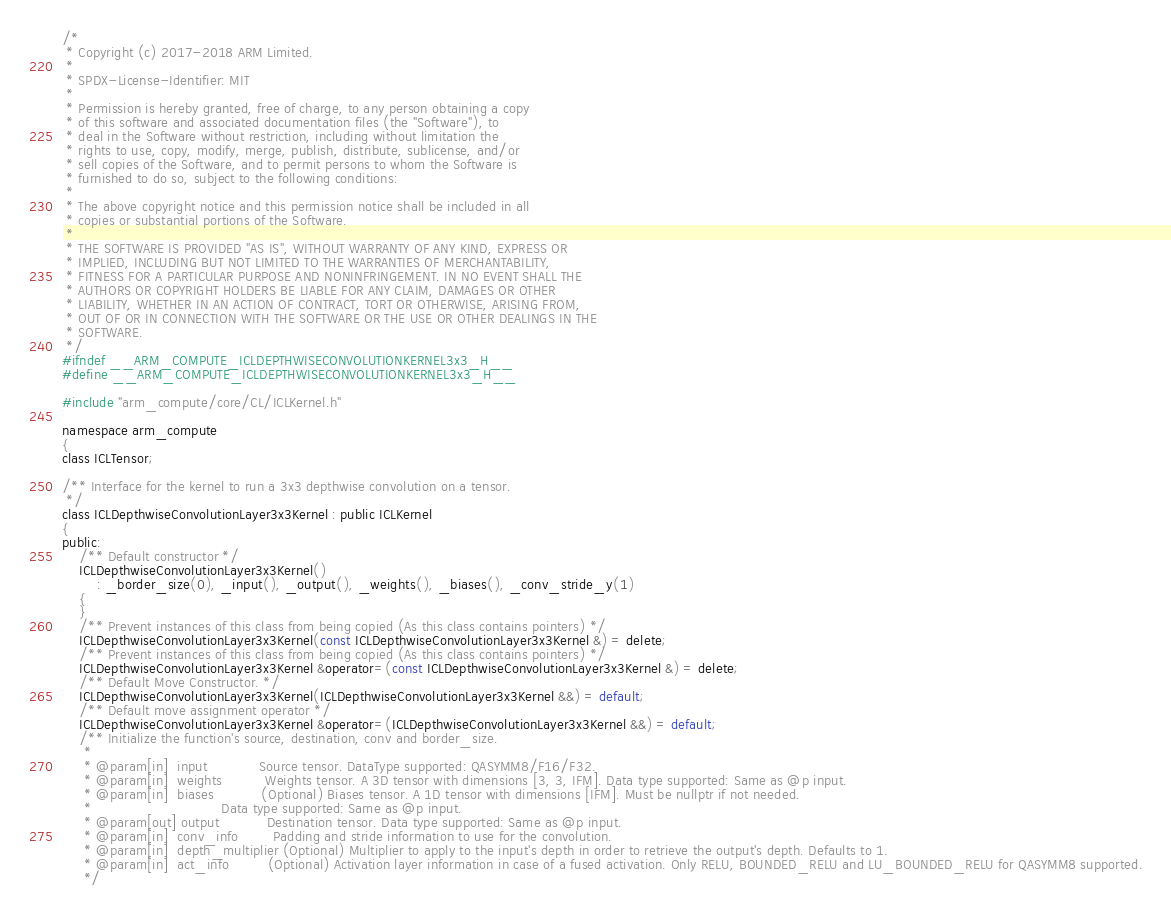Convert code to text. <code><loc_0><loc_0><loc_500><loc_500><_C_>/*
 * Copyright (c) 2017-2018 ARM Limited.
 *
 * SPDX-License-Identifier: MIT
 *
 * Permission is hereby granted, free of charge, to any person obtaining a copy
 * of this software and associated documentation files (the "Software"), to
 * deal in the Software without restriction, including without limitation the
 * rights to use, copy, modify, merge, publish, distribute, sublicense, and/or
 * sell copies of the Software, and to permit persons to whom the Software is
 * furnished to do so, subject to the following conditions:
 *
 * The above copyright notice and this permission notice shall be included in all
 * copies or substantial portions of the Software.
 *
 * THE SOFTWARE IS PROVIDED "AS IS", WITHOUT WARRANTY OF ANY KIND, EXPRESS OR
 * IMPLIED, INCLUDING BUT NOT LIMITED TO THE WARRANTIES OF MERCHANTABILITY,
 * FITNESS FOR A PARTICULAR PURPOSE AND NONINFRINGEMENT. IN NO EVENT SHALL THE
 * AUTHORS OR COPYRIGHT HOLDERS BE LIABLE FOR ANY CLAIM, DAMAGES OR OTHER
 * LIABILITY, WHETHER IN AN ACTION OF CONTRACT, TORT OR OTHERWISE, ARISING FROM,
 * OUT OF OR IN CONNECTION WITH THE SOFTWARE OR THE USE OR OTHER DEALINGS IN THE
 * SOFTWARE.
 */
#ifndef __ARM_COMPUTE_ICLDEPTHWISECONVOLUTIONKERNEL3x3_H__
#define __ARM_COMPUTE_ICLDEPTHWISECONVOLUTIONKERNEL3x3_H__

#include "arm_compute/core/CL/ICLKernel.h"

namespace arm_compute
{
class ICLTensor;

/** Interface for the kernel to run a 3x3 depthwise convolution on a tensor.
 */
class ICLDepthwiseConvolutionLayer3x3Kernel : public ICLKernel
{
public:
    /** Default constructor */
    ICLDepthwiseConvolutionLayer3x3Kernel()
        : _border_size(0), _input(), _output(), _weights(), _biases(), _conv_stride_y(1)
    {
    }
    /** Prevent instances of this class from being copied (As this class contains pointers) */
    ICLDepthwiseConvolutionLayer3x3Kernel(const ICLDepthwiseConvolutionLayer3x3Kernel &) = delete;
    /** Prevent instances of this class from being copied (As this class contains pointers) */
    ICLDepthwiseConvolutionLayer3x3Kernel &operator=(const ICLDepthwiseConvolutionLayer3x3Kernel &) = delete;
    /** Default Move Constructor. */
    ICLDepthwiseConvolutionLayer3x3Kernel(ICLDepthwiseConvolutionLayer3x3Kernel &&) = default;
    /** Default move assignment operator */
    ICLDepthwiseConvolutionLayer3x3Kernel &operator=(ICLDepthwiseConvolutionLayer3x3Kernel &&) = default;
    /** Initialize the function's source, destination, conv and border_size.
     *
     * @param[in]  input            Source tensor. DataType supported: QASYMM8/F16/F32.
     * @param[in]  weights          Weights tensor. A 3D tensor with dimensions [3, 3, IFM]. Data type supported: Same as @p input.
     * @param[in]  biases           (Optional) Biases tensor. A 1D tensor with dimensions [IFM]. Must be nullptr if not needed.
     *                              Data type supported: Same as @p input.
     * @param[out] output           Destination tensor. Data type supported: Same as @p input.
     * @param[in]  conv_info        Padding and stride information to use for the convolution.
     * @param[in]  depth_multiplier (Optional) Multiplier to apply to the input's depth in order to retrieve the output's depth. Defaults to 1.
     * @param[in]  act_info         (Optional) Activation layer information in case of a fused activation. Only RELU, BOUNDED_RELU and LU_BOUNDED_RELU for QASYMM8 supported.
     */</code> 